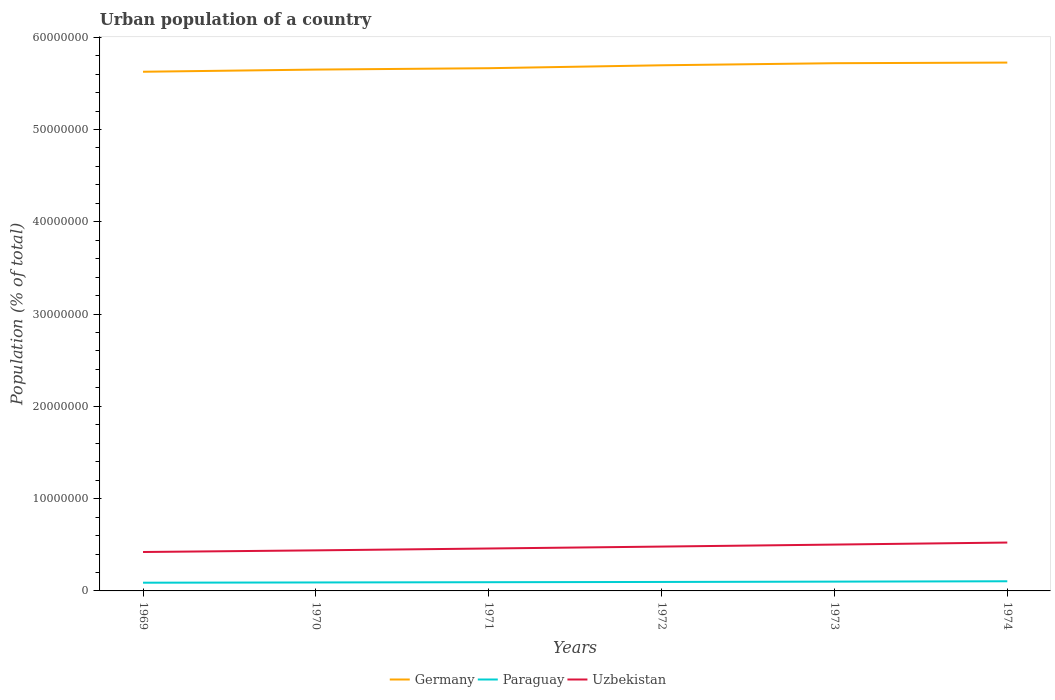Does the line corresponding to Uzbekistan intersect with the line corresponding to Paraguay?
Offer a very short reply. No. Across all years, what is the maximum urban population in Uzbekistan?
Your answer should be very brief. 4.22e+06. In which year was the urban population in Germany maximum?
Ensure brevity in your answer.  1969. What is the total urban population in Germany in the graph?
Provide a succinct answer. -7.58e+05. What is the difference between the highest and the second highest urban population in Paraguay?
Your response must be concise. 1.57e+05. How many years are there in the graph?
Keep it short and to the point. 6. Are the values on the major ticks of Y-axis written in scientific E-notation?
Provide a succinct answer. No. How are the legend labels stacked?
Your response must be concise. Horizontal. What is the title of the graph?
Your answer should be very brief. Urban population of a country. What is the label or title of the Y-axis?
Provide a succinct answer. Population (% of total). What is the Population (% of total) of Germany in 1969?
Provide a succinct answer. 5.63e+07. What is the Population (% of total) in Paraguay in 1969?
Your answer should be compact. 8.90e+05. What is the Population (% of total) of Uzbekistan in 1969?
Give a very brief answer. 4.22e+06. What is the Population (% of total) of Germany in 1970?
Give a very brief answer. 5.65e+07. What is the Population (% of total) of Paraguay in 1970?
Your response must be concise. 9.17e+05. What is the Population (% of total) in Uzbekistan in 1970?
Give a very brief answer. 4.40e+06. What is the Population (% of total) of Germany in 1971?
Your answer should be compact. 5.66e+07. What is the Population (% of total) of Paraguay in 1971?
Keep it short and to the point. 9.44e+05. What is the Population (% of total) of Uzbekistan in 1971?
Give a very brief answer. 4.60e+06. What is the Population (% of total) in Germany in 1972?
Make the answer very short. 5.70e+07. What is the Population (% of total) in Paraguay in 1972?
Your answer should be very brief. 9.71e+05. What is the Population (% of total) of Uzbekistan in 1972?
Provide a succinct answer. 4.81e+06. What is the Population (% of total) of Germany in 1973?
Your answer should be very brief. 5.72e+07. What is the Population (% of total) of Paraguay in 1973?
Offer a very short reply. 1.01e+06. What is the Population (% of total) in Uzbekistan in 1973?
Offer a terse response. 5.02e+06. What is the Population (% of total) in Germany in 1974?
Ensure brevity in your answer.  5.73e+07. What is the Population (% of total) in Paraguay in 1974?
Keep it short and to the point. 1.05e+06. What is the Population (% of total) in Uzbekistan in 1974?
Ensure brevity in your answer.  5.24e+06. Across all years, what is the maximum Population (% of total) of Germany?
Your answer should be very brief. 5.73e+07. Across all years, what is the maximum Population (% of total) in Paraguay?
Make the answer very short. 1.05e+06. Across all years, what is the maximum Population (% of total) in Uzbekistan?
Make the answer very short. 5.24e+06. Across all years, what is the minimum Population (% of total) in Germany?
Your answer should be compact. 5.63e+07. Across all years, what is the minimum Population (% of total) in Paraguay?
Your answer should be very brief. 8.90e+05. Across all years, what is the minimum Population (% of total) of Uzbekistan?
Provide a short and direct response. 4.22e+06. What is the total Population (% of total) in Germany in the graph?
Provide a succinct answer. 3.41e+08. What is the total Population (% of total) in Paraguay in the graph?
Give a very brief answer. 5.78e+06. What is the total Population (% of total) of Uzbekistan in the graph?
Your answer should be very brief. 2.83e+07. What is the difference between the Population (% of total) in Germany in 1969 and that in 1970?
Your answer should be very brief. -2.37e+05. What is the difference between the Population (% of total) in Paraguay in 1969 and that in 1970?
Your answer should be compact. -2.68e+04. What is the difference between the Population (% of total) of Uzbekistan in 1969 and that in 1970?
Offer a very short reply. -1.79e+05. What is the difference between the Population (% of total) in Germany in 1969 and that in 1971?
Offer a very short reply. -3.86e+05. What is the difference between the Population (% of total) of Paraguay in 1969 and that in 1971?
Your answer should be very brief. -5.37e+04. What is the difference between the Population (% of total) of Uzbekistan in 1969 and that in 1971?
Ensure brevity in your answer.  -3.79e+05. What is the difference between the Population (% of total) in Germany in 1969 and that in 1972?
Your response must be concise. -7.02e+05. What is the difference between the Population (% of total) of Paraguay in 1969 and that in 1972?
Keep it short and to the point. -8.08e+04. What is the difference between the Population (% of total) in Uzbekistan in 1969 and that in 1972?
Offer a terse response. -5.89e+05. What is the difference between the Population (% of total) of Germany in 1969 and that in 1973?
Your answer should be compact. -9.27e+05. What is the difference between the Population (% of total) in Paraguay in 1969 and that in 1973?
Keep it short and to the point. -1.18e+05. What is the difference between the Population (% of total) of Uzbekistan in 1969 and that in 1973?
Your answer should be very brief. -8.05e+05. What is the difference between the Population (% of total) in Germany in 1969 and that in 1974?
Your response must be concise. -9.94e+05. What is the difference between the Population (% of total) of Paraguay in 1969 and that in 1974?
Give a very brief answer. -1.57e+05. What is the difference between the Population (% of total) of Uzbekistan in 1969 and that in 1974?
Your answer should be very brief. -1.03e+06. What is the difference between the Population (% of total) in Germany in 1970 and that in 1971?
Your answer should be compact. -1.49e+05. What is the difference between the Population (% of total) of Paraguay in 1970 and that in 1971?
Your answer should be compact. -2.69e+04. What is the difference between the Population (% of total) of Uzbekistan in 1970 and that in 1971?
Ensure brevity in your answer.  -2.01e+05. What is the difference between the Population (% of total) in Germany in 1970 and that in 1972?
Give a very brief answer. -4.66e+05. What is the difference between the Population (% of total) in Paraguay in 1970 and that in 1972?
Provide a succinct answer. -5.41e+04. What is the difference between the Population (% of total) of Uzbekistan in 1970 and that in 1972?
Your response must be concise. -4.10e+05. What is the difference between the Population (% of total) in Germany in 1970 and that in 1973?
Keep it short and to the point. -6.90e+05. What is the difference between the Population (% of total) in Paraguay in 1970 and that in 1973?
Provide a succinct answer. -9.12e+04. What is the difference between the Population (% of total) of Uzbekistan in 1970 and that in 1973?
Your answer should be compact. -6.26e+05. What is the difference between the Population (% of total) of Germany in 1970 and that in 1974?
Your response must be concise. -7.58e+05. What is the difference between the Population (% of total) in Paraguay in 1970 and that in 1974?
Give a very brief answer. -1.30e+05. What is the difference between the Population (% of total) in Uzbekistan in 1970 and that in 1974?
Your answer should be compact. -8.47e+05. What is the difference between the Population (% of total) in Germany in 1971 and that in 1972?
Offer a very short reply. -3.17e+05. What is the difference between the Population (% of total) of Paraguay in 1971 and that in 1972?
Make the answer very short. -2.72e+04. What is the difference between the Population (% of total) of Uzbekistan in 1971 and that in 1972?
Provide a succinct answer. -2.10e+05. What is the difference between the Population (% of total) in Germany in 1971 and that in 1973?
Your answer should be compact. -5.41e+05. What is the difference between the Population (% of total) in Paraguay in 1971 and that in 1973?
Ensure brevity in your answer.  -6.43e+04. What is the difference between the Population (% of total) in Uzbekistan in 1971 and that in 1973?
Offer a very short reply. -4.26e+05. What is the difference between the Population (% of total) in Germany in 1971 and that in 1974?
Offer a very short reply. -6.09e+05. What is the difference between the Population (% of total) of Paraguay in 1971 and that in 1974?
Ensure brevity in your answer.  -1.03e+05. What is the difference between the Population (% of total) in Uzbekistan in 1971 and that in 1974?
Provide a short and direct response. -6.46e+05. What is the difference between the Population (% of total) of Germany in 1972 and that in 1973?
Your answer should be compact. -2.25e+05. What is the difference between the Population (% of total) of Paraguay in 1972 and that in 1973?
Offer a terse response. -3.71e+04. What is the difference between the Population (% of total) of Uzbekistan in 1972 and that in 1973?
Your response must be concise. -2.16e+05. What is the difference between the Population (% of total) of Germany in 1972 and that in 1974?
Your response must be concise. -2.92e+05. What is the difference between the Population (% of total) of Paraguay in 1972 and that in 1974?
Keep it short and to the point. -7.60e+04. What is the difference between the Population (% of total) of Uzbekistan in 1972 and that in 1974?
Keep it short and to the point. -4.37e+05. What is the difference between the Population (% of total) in Germany in 1973 and that in 1974?
Your response must be concise. -6.73e+04. What is the difference between the Population (% of total) in Paraguay in 1973 and that in 1974?
Your answer should be compact. -3.89e+04. What is the difference between the Population (% of total) of Uzbekistan in 1973 and that in 1974?
Your answer should be compact. -2.20e+05. What is the difference between the Population (% of total) of Germany in 1969 and the Population (% of total) of Paraguay in 1970?
Offer a terse response. 5.53e+07. What is the difference between the Population (% of total) of Germany in 1969 and the Population (% of total) of Uzbekistan in 1970?
Make the answer very short. 5.19e+07. What is the difference between the Population (% of total) of Paraguay in 1969 and the Population (% of total) of Uzbekistan in 1970?
Give a very brief answer. -3.51e+06. What is the difference between the Population (% of total) of Germany in 1969 and the Population (% of total) of Paraguay in 1971?
Provide a succinct answer. 5.53e+07. What is the difference between the Population (% of total) in Germany in 1969 and the Population (% of total) in Uzbekistan in 1971?
Your answer should be very brief. 5.17e+07. What is the difference between the Population (% of total) of Paraguay in 1969 and the Population (% of total) of Uzbekistan in 1971?
Provide a short and direct response. -3.71e+06. What is the difference between the Population (% of total) in Germany in 1969 and the Population (% of total) in Paraguay in 1972?
Provide a short and direct response. 5.53e+07. What is the difference between the Population (% of total) in Germany in 1969 and the Population (% of total) in Uzbekistan in 1972?
Provide a succinct answer. 5.15e+07. What is the difference between the Population (% of total) of Paraguay in 1969 and the Population (% of total) of Uzbekistan in 1972?
Ensure brevity in your answer.  -3.92e+06. What is the difference between the Population (% of total) in Germany in 1969 and the Population (% of total) in Paraguay in 1973?
Provide a succinct answer. 5.53e+07. What is the difference between the Population (% of total) in Germany in 1969 and the Population (% of total) in Uzbekistan in 1973?
Offer a very short reply. 5.12e+07. What is the difference between the Population (% of total) in Paraguay in 1969 and the Population (% of total) in Uzbekistan in 1973?
Your answer should be compact. -4.13e+06. What is the difference between the Population (% of total) of Germany in 1969 and the Population (% of total) of Paraguay in 1974?
Your answer should be compact. 5.52e+07. What is the difference between the Population (% of total) of Germany in 1969 and the Population (% of total) of Uzbekistan in 1974?
Make the answer very short. 5.10e+07. What is the difference between the Population (% of total) of Paraguay in 1969 and the Population (% of total) of Uzbekistan in 1974?
Your response must be concise. -4.35e+06. What is the difference between the Population (% of total) of Germany in 1970 and the Population (% of total) of Paraguay in 1971?
Keep it short and to the point. 5.56e+07. What is the difference between the Population (% of total) in Germany in 1970 and the Population (% of total) in Uzbekistan in 1971?
Offer a very short reply. 5.19e+07. What is the difference between the Population (% of total) in Paraguay in 1970 and the Population (% of total) in Uzbekistan in 1971?
Make the answer very short. -3.68e+06. What is the difference between the Population (% of total) of Germany in 1970 and the Population (% of total) of Paraguay in 1972?
Give a very brief answer. 5.55e+07. What is the difference between the Population (% of total) in Germany in 1970 and the Population (% of total) in Uzbekistan in 1972?
Your answer should be compact. 5.17e+07. What is the difference between the Population (% of total) in Paraguay in 1970 and the Population (% of total) in Uzbekistan in 1972?
Keep it short and to the point. -3.89e+06. What is the difference between the Population (% of total) in Germany in 1970 and the Population (% of total) in Paraguay in 1973?
Offer a very short reply. 5.55e+07. What is the difference between the Population (% of total) of Germany in 1970 and the Population (% of total) of Uzbekistan in 1973?
Make the answer very short. 5.15e+07. What is the difference between the Population (% of total) in Paraguay in 1970 and the Population (% of total) in Uzbekistan in 1973?
Keep it short and to the point. -4.11e+06. What is the difference between the Population (% of total) of Germany in 1970 and the Population (% of total) of Paraguay in 1974?
Your answer should be very brief. 5.54e+07. What is the difference between the Population (% of total) in Germany in 1970 and the Population (% of total) in Uzbekistan in 1974?
Your answer should be compact. 5.13e+07. What is the difference between the Population (% of total) of Paraguay in 1970 and the Population (% of total) of Uzbekistan in 1974?
Offer a terse response. -4.33e+06. What is the difference between the Population (% of total) of Germany in 1971 and the Population (% of total) of Paraguay in 1972?
Provide a short and direct response. 5.57e+07. What is the difference between the Population (% of total) in Germany in 1971 and the Population (% of total) in Uzbekistan in 1972?
Your answer should be very brief. 5.18e+07. What is the difference between the Population (% of total) of Paraguay in 1971 and the Population (% of total) of Uzbekistan in 1972?
Provide a succinct answer. -3.86e+06. What is the difference between the Population (% of total) of Germany in 1971 and the Population (% of total) of Paraguay in 1973?
Offer a terse response. 5.56e+07. What is the difference between the Population (% of total) in Germany in 1971 and the Population (% of total) in Uzbekistan in 1973?
Your response must be concise. 5.16e+07. What is the difference between the Population (% of total) in Paraguay in 1971 and the Population (% of total) in Uzbekistan in 1973?
Ensure brevity in your answer.  -4.08e+06. What is the difference between the Population (% of total) in Germany in 1971 and the Population (% of total) in Paraguay in 1974?
Make the answer very short. 5.56e+07. What is the difference between the Population (% of total) of Germany in 1971 and the Population (% of total) of Uzbekistan in 1974?
Give a very brief answer. 5.14e+07. What is the difference between the Population (% of total) in Paraguay in 1971 and the Population (% of total) in Uzbekistan in 1974?
Make the answer very short. -4.30e+06. What is the difference between the Population (% of total) in Germany in 1972 and the Population (% of total) in Paraguay in 1973?
Offer a very short reply. 5.60e+07. What is the difference between the Population (% of total) of Germany in 1972 and the Population (% of total) of Uzbekistan in 1973?
Provide a succinct answer. 5.19e+07. What is the difference between the Population (% of total) in Paraguay in 1972 and the Population (% of total) in Uzbekistan in 1973?
Provide a succinct answer. -4.05e+06. What is the difference between the Population (% of total) of Germany in 1972 and the Population (% of total) of Paraguay in 1974?
Provide a succinct answer. 5.59e+07. What is the difference between the Population (% of total) of Germany in 1972 and the Population (% of total) of Uzbekistan in 1974?
Provide a short and direct response. 5.17e+07. What is the difference between the Population (% of total) of Paraguay in 1972 and the Population (% of total) of Uzbekistan in 1974?
Give a very brief answer. -4.27e+06. What is the difference between the Population (% of total) in Germany in 1973 and the Population (% of total) in Paraguay in 1974?
Give a very brief answer. 5.61e+07. What is the difference between the Population (% of total) of Germany in 1973 and the Population (% of total) of Uzbekistan in 1974?
Your response must be concise. 5.19e+07. What is the difference between the Population (% of total) in Paraguay in 1973 and the Population (% of total) in Uzbekistan in 1974?
Provide a succinct answer. -4.23e+06. What is the average Population (% of total) in Germany per year?
Ensure brevity in your answer.  5.68e+07. What is the average Population (% of total) of Paraguay per year?
Make the answer very short. 9.63e+05. What is the average Population (% of total) of Uzbekistan per year?
Keep it short and to the point. 4.71e+06. In the year 1969, what is the difference between the Population (% of total) in Germany and Population (% of total) in Paraguay?
Offer a very short reply. 5.54e+07. In the year 1969, what is the difference between the Population (% of total) of Germany and Population (% of total) of Uzbekistan?
Provide a succinct answer. 5.20e+07. In the year 1969, what is the difference between the Population (% of total) in Paraguay and Population (% of total) in Uzbekistan?
Provide a succinct answer. -3.33e+06. In the year 1970, what is the difference between the Population (% of total) in Germany and Population (% of total) in Paraguay?
Offer a terse response. 5.56e+07. In the year 1970, what is the difference between the Population (% of total) in Germany and Population (% of total) in Uzbekistan?
Provide a succinct answer. 5.21e+07. In the year 1970, what is the difference between the Population (% of total) in Paraguay and Population (% of total) in Uzbekistan?
Your answer should be compact. -3.48e+06. In the year 1971, what is the difference between the Population (% of total) in Germany and Population (% of total) in Paraguay?
Your answer should be very brief. 5.57e+07. In the year 1971, what is the difference between the Population (% of total) of Germany and Population (% of total) of Uzbekistan?
Keep it short and to the point. 5.20e+07. In the year 1971, what is the difference between the Population (% of total) of Paraguay and Population (% of total) of Uzbekistan?
Offer a terse response. -3.65e+06. In the year 1972, what is the difference between the Population (% of total) in Germany and Population (% of total) in Paraguay?
Make the answer very short. 5.60e+07. In the year 1972, what is the difference between the Population (% of total) of Germany and Population (% of total) of Uzbekistan?
Offer a terse response. 5.22e+07. In the year 1972, what is the difference between the Population (% of total) in Paraguay and Population (% of total) in Uzbekistan?
Ensure brevity in your answer.  -3.83e+06. In the year 1973, what is the difference between the Population (% of total) of Germany and Population (% of total) of Paraguay?
Give a very brief answer. 5.62e+07. In the year 1973, what is the difference between the Population (% of total) in Germany and Population (% of total) in Uzbekistan?
Offer a very short reply. 5.22e+07. In the year 1973, what is the difference between the Population (% of total) in Paraguay and Population (% of total) in Uzbekistan?
Offer a terse response. -4.01e+06. In the year 1974, what is the difference between the Population (% of total) in Germany and Population (% of total) in Paraguay?
Ensure brevity in your answer.  5.62e+07. In the year 1974, what is the difference between the Population (% of total) of Germany and Population (% of total) of Uzbekistan?
Your answer should be very brief. 5.20e+07. In the year 1974, what is the difference between the Population (% of total) of Paraguay and Population (% of total) of Uzbekistan?
Offer a terse response. -4.20e+06. What is the ratio of the Population (% of total) of Germany in 1969 to that in 1970?
Provide a short and direct response. 1. What is the ratio of the Population (% of total) in Paraguay in 1969 to that in 1970?
Keep it short and to the point. 0.97. What is the ratio of the Population (% of total) in Uzbekistan in 1969 to that in 1970?
Offer a terse response. 0.96. What is the ratio of the Population (% of total) of Paraguay in 1969 to that in 1971?
Your answer should be compact. 0.94. What is the ratio of the Population (% of total) of Uzbekistan in 1969 to that in 1971?
Provide a succinct answer. 0.92. What is the ratio of the Population (% of total) of Germany in 1969 to that in 1972?
Your answer should be compact. 0.99. What is the ratio of the Population (% of total) of Paraguay in 1969 to that in 1972?
Offer a very short reply. 0.92. What is the ratio of the Population (% of total) in Uzbekistan in 1969 to that in 1972?
Offer a very short reply. 0.88. What is the ratio of the Population (% of total) of Germany in 1969 to that in 1973?
Make the answer very short. 0.98. What is the ratio of the Population (% of total) of Paraguay in 1969 to that in 1973?
Provide a succinct answer. 0.88. What is the ratio of the Population (% of total) of Uzbekistan in 1969 to that in 1973?
Offer a terse response. 0.84. What is the ratio of the Population (% of total) in Germany in 1969 to that in 1974?
Give a very brief answer. 0.98. What is the ratio of the Population (% of total) in Paraguay in 1969 to that in 1974?
Ensure brevity in your answer.  0.85. What is the ratio of the Population (% of total) in Uzbekistan in 1969 to that in 1974?
Your answer should be very brief. 0.8. What is the ratio of the Population (% of total) in Paraguay in 1970 to that in 1971?
Keep it short and to the point. 0.97. What is the ratio of the Population (% of total) of Uzbekistan in 1970 to that in 1971?
Your response must be concise. 0.96. What is the ratio of the Population (% of total) of Germany in 1970 to that in 1972?
Provide a short and direct response. 0.99. What is the ratio of the Population (% of total) of Paraguay in 1970 to that in 1972?
Provide a short and direct response. 0.94. What is the ratio of the Population (% of total) of Uzbekistan in 1970 to that in 1972?
Your answer should be very brief. 0.91. What is the ratio of the Population (% of total) of Germany in 1970 to that in 1973?
Your answer should be very brief. 0.99. What is the ratio of the Population (% of total) in Paraguay in 1970 to that in 1973?
Keep it short and to the point. 0.91. What is the ratio of the Population (% of total) in Uzbekistan in 1970 to that in 1973?
Offer a very short reply. 0.88. What is the ratio of the Population (% of total) in Germany in 1970 to that in 1974?
Keep it short and to the point. 0.99. What is the ratio of the Population (% of total) of Paraguay in 1970 to that in 1974?
Provide a succinct answer. 0.88. What is the ratio of the Population (% of total) of Uzbekistan in 1970 to that in 1974?
Provide a short and direct response. 0.84. What is the ratio of the Population (% of total) in Uzbekistan in 1971 to that in 1972?
Your answer should be very brief. 0.96. What is the ratio of the Population (% of total) of Paraguay in 1971 to that in 1973?
Your response must be concise. 0.94. What is the ratio of the Population (% of total) in Uzbekistan in 1971 to that in 1973?
Provide a succinct answer. 0.92. What is the ratio of the Population (% of total) of Paraguay in 1971 to that in 1974?
Provide a short and direct response. 0.9. What is the ratio of the Population (% of total) in Uzbekistan in 1971 to that in 1974?
Your answer should be very brief. 0.88. What is the ratio of the Population (% of total) in Germany in 1972 to that in 1973?
Give a very brief answer. 1. What is the ratio of the Population (% of total) in Paraguay in 1972 to that in 1973?
Give a very brief answer. 0.96. What is the ratio of the Population (% of total) of Uzbekistan in 1972 to that in 1973?
Provide a succinct answer. 0.96. What is the ratio of the Population (% of total) of Germany in 1972 to that in 1974?
Your answer should be very brief. 0.99. What is the ratio of the Population (% of total) of Paraguay in 1972 to that in 1974?
Provide a short and direct response. 0.93. What is the ratio of the Population (% of total) in Paraguay in 1973 to that in 1974?
Your response must be concise. 0.96. What is the ratio of the Population (% of total) in Uzbekistan in 1973 to that in 1974?
Provide a succinct answer. 0.96. What is the difference between the highest and the second highest Population (% of total) in Germany?
Offer a terse response. 6.73e+04. What is the difference between the highest and the second highest Population (% of total) in Paraguay?
Your answer should be compact. 3.89e+04. What is the difference between the highest and the second highest Population (% of total) of Uzbekistan?
Your answer should be very brief. 2.20e+05. What is the difference between the highest and the lowest Population (% of total) of Germany?
Your answer should be very brief. 9.94e+05. What is the difference between the highest and the lowest Population (% of total) of Paraguay?
Keep it short and to the point. 1.57e+05. What is the difference between the highest and the lowest Population (% of total) in Uzbekistan?
Your answer should be compact. 1.03e+06. 